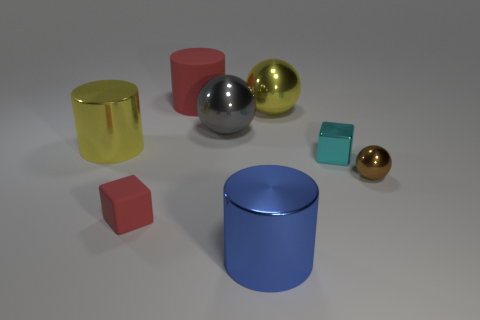Add 1 big shiny balls. How many objects exist? 9 Subtract all tiny brown shiny balls. How many balls are left? 2 Subtract all blue cylinders. How many cylinders are left? 2 Subtract all spheres. How many objects are left? 5 Subtract all purple blocks. Subtract all brown spheres. How many blocks are left? 2 Subtract all tiny metal objects. Subtract all large blue objects. How many objects are left? 5 Add 1 big red things. How many big red things are left? 2 Add 3 big blue cylinders. How many big blue cylinders exist? 4 Subtract 0 purple cylinders. How many objects are left? 8 